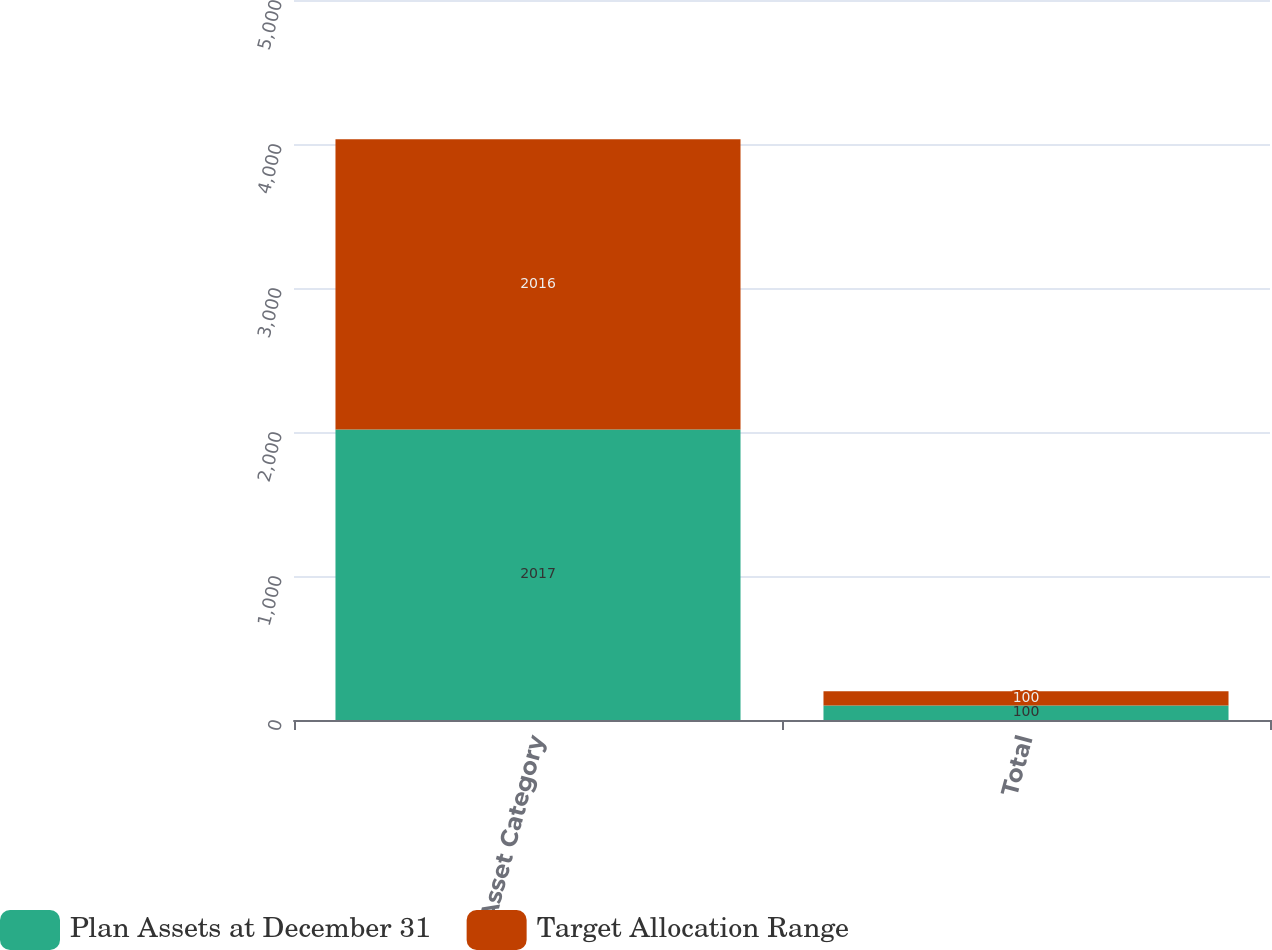Convert chart. <chart><loc_0><loc_0><loc_500><loc_500><stacked_bar_chart><ecel><fcel>Asset Category<fcel>Total<nl><fcel>Plan Assets at December 31<fcel>2017<fcel>100<nl><fcel>Target Allocation Range<fcel>2016<fcel>100<nl></chart> 